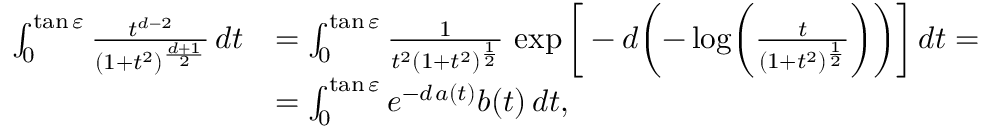<formula> <loc_0><loc_0><loc_500><loc_500>\begin{array} { r l } { \int _ { 0 } ^ { \tan \varepsilon } \frac { t ^ { d - 2 } } { ( 1 + t ^ { 2 } ) ^ { \frac { d + 1 } { 2 } } } \, d t } & { = \int _ { 0 } ^ { \tan \varepsilon } \frac { 1 } { t ^ { 2 } ( 1 + t ^ { 2 } ) ^ { \frac { 1 } { 2 } } } \, \exp \left [ - d \left ( - \log \left ( \frac { t } { ( 1 + t ^ { 2 } ) ^ { \frac { 1 } { 2 } } } \right ) \right ) \right ] \, d t = } \\ & { = \int _ { 0 } ^ { \tan \varepsilon } e ^ { - d \, a ( t ) } b ( t ) \, d t , } \end{array}</formula> 